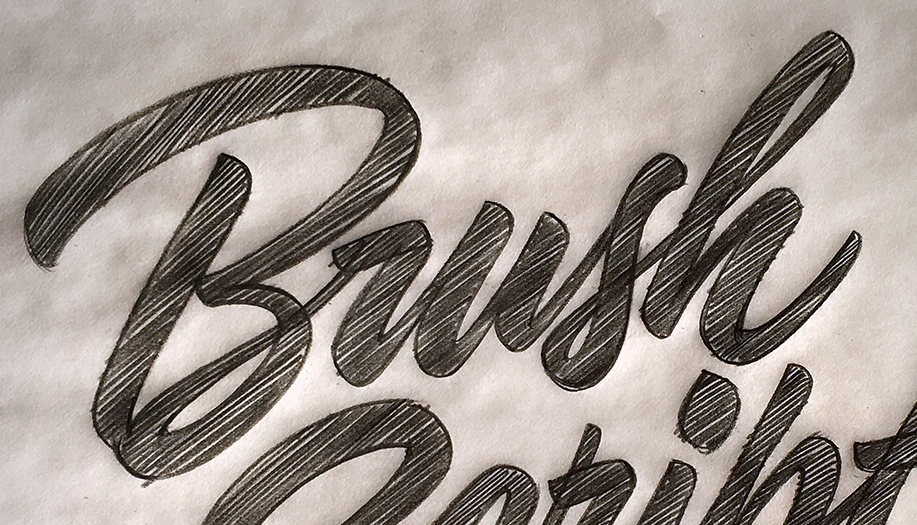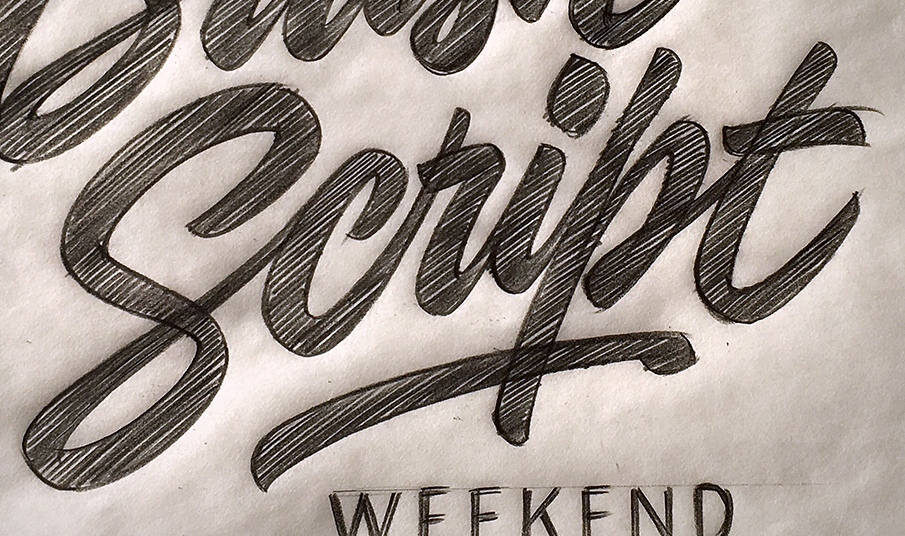What text appears in these images from left to right, separated by a semicolon? Brush; Script 